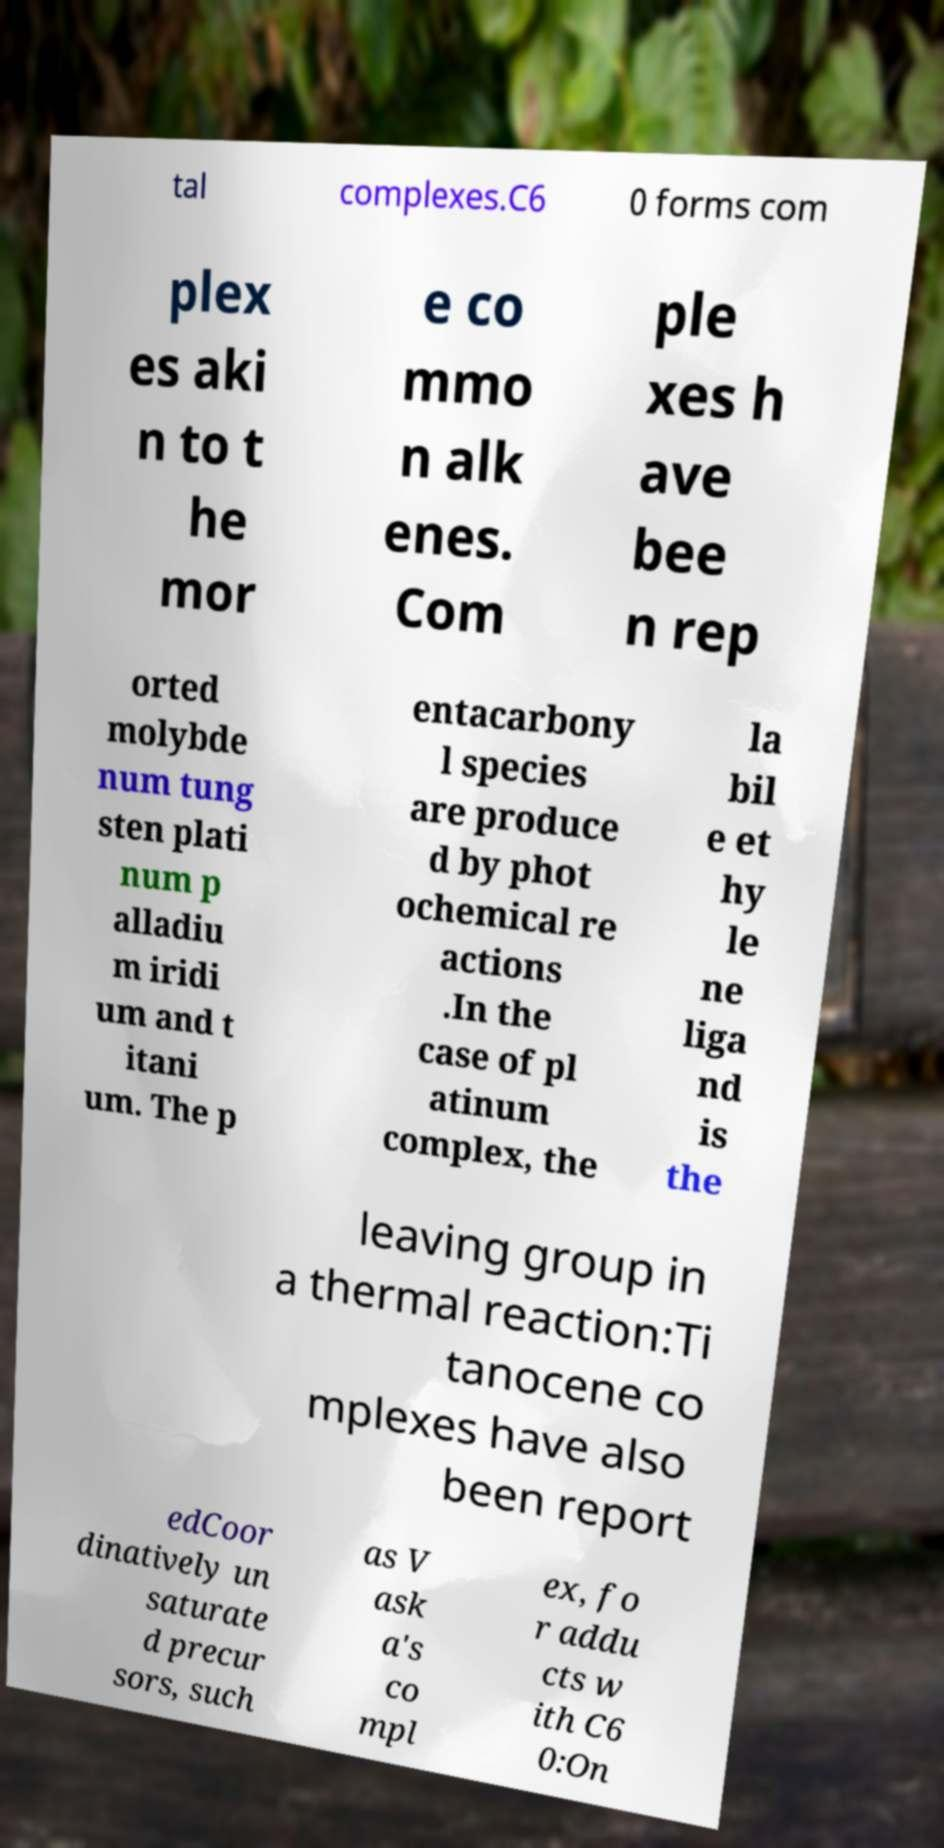Can you read and provide the text displayed in the image?This photo seems to have some interesting text. Can you extract and type it out for me? tal complexes.C6 0 forms com plex es aki n to t he mor e co mmo n alk enes. Com ple xes h ave bee n rep orted molybde num tung sten plati num p alladiu m iridi um and t itani um. The p entacarbony l species are produce d by phot ochemical re actions .In the case of pl atinum complex, the la bil e et hy le ne liga nd is the leaving group in a thermal reaction:Ti tanocene co mplexes have also been report edCoor dinatively un saturate d precur sors, such as V ask a's co mpl ex, fo r addu cts w ith C6 0:On 